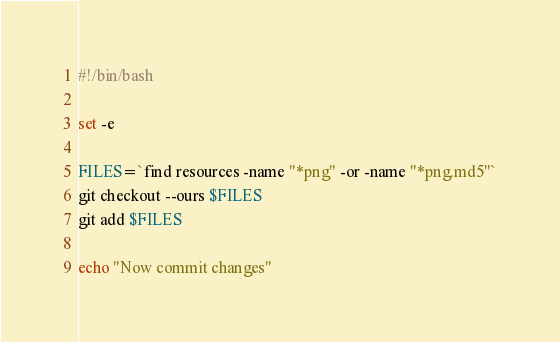Convert code to text. <code><loc_0><loc_0><loc_500><loc_500><_Bash_>#!/bin/bash

set -e

FILES=`find resources -name "*png" -or -name "*png.md5"`
git checkout --ours $FILES
git add $FILES

echo "Now commit changes"
</code> 